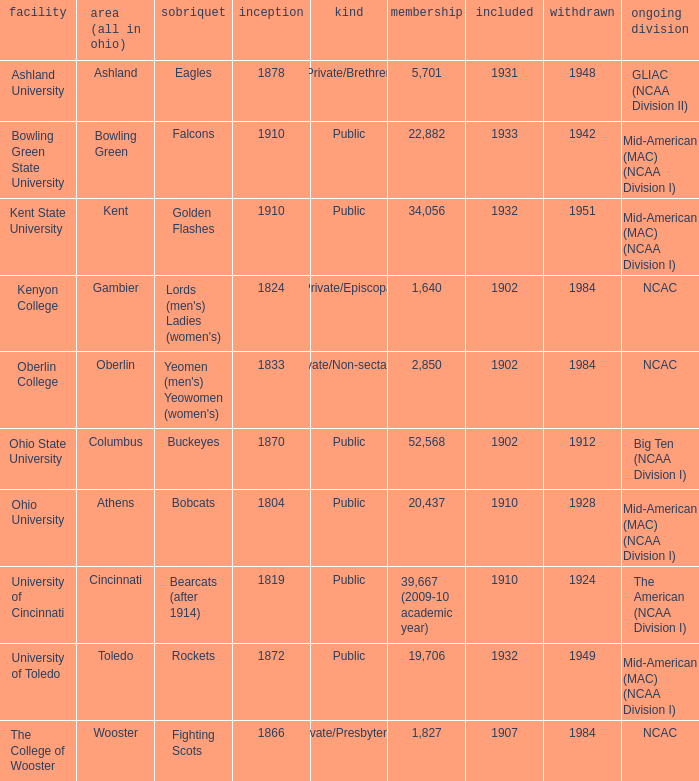Could you parse the entire table? {'header': ['facility', 'area (all in ohio)', 'sobriquet', 'inception', 'kind', 'membership', 'included', 'withdrawn', 'ongoing division'], 'rows': [['Ashland University', 'Ashland', 'Eagles', '1878', 'Private/Brethren', '5,701', '1931', '1948', 'GLIAC (NCAA Division II)'], ['Bowling Green State University', 'Bowling Green', 'Falcons', '1910', 'Public', '22,882', '1933', '1942', 'Mid-American (MAC) (NCAA Division I)'], ['Kent State University', 'Kent', 'Golden Flashes', '1910', 'Public', '34,056', '1932', '1951', 'Mid-American (MAC) (NCAA Division I)'], ['Kenyon College', 'Gambier', "Lords (men's) Ladies (women's)", '1824', 'Private/Episcopal', '1,640', '1902', '1984', 'NCAC'], ['Oberlin College', 'Oberlin', "Yeomen (men's) Yeowomen (women's)", '1833', 'Private/Non-sectarian', '2,850', '1902', '1984', 'NCAC'], ['Ohio State University', 'Columbus', 'Buckeyes', '1870', 'Public', '52,568', '1902', '1912', 'Big Ten (NCAA Division I)'], ['Ohio University', 'Athens', 'Bobcats', '1804', 'Public', '20,437', '1910', '1928', 'Mid-American (MAC) (NCAA Division I)'], ['University of Cincinnati', 'Cincinnati', 'Bearcats (after 1914)', '1819', 'Public', '39,667 (2009-10 academic year)', '1910', '1924', 'The American (NCAA Division I)'], ['University of Toledo', 'Toledo', 'Rockets', '1872', 'Public', '19,706', '1932', '1949', 'Mid-American (MAC) (NCAA Division I)'], ['The College of Wooster', 'Wooster', 'Fighting Scots', '1866', 'Private/Presbyterian', '1,827', '1907', '1984', 'NCAC']]} Which year did enrolled Gambier members leave? 1984.0. 